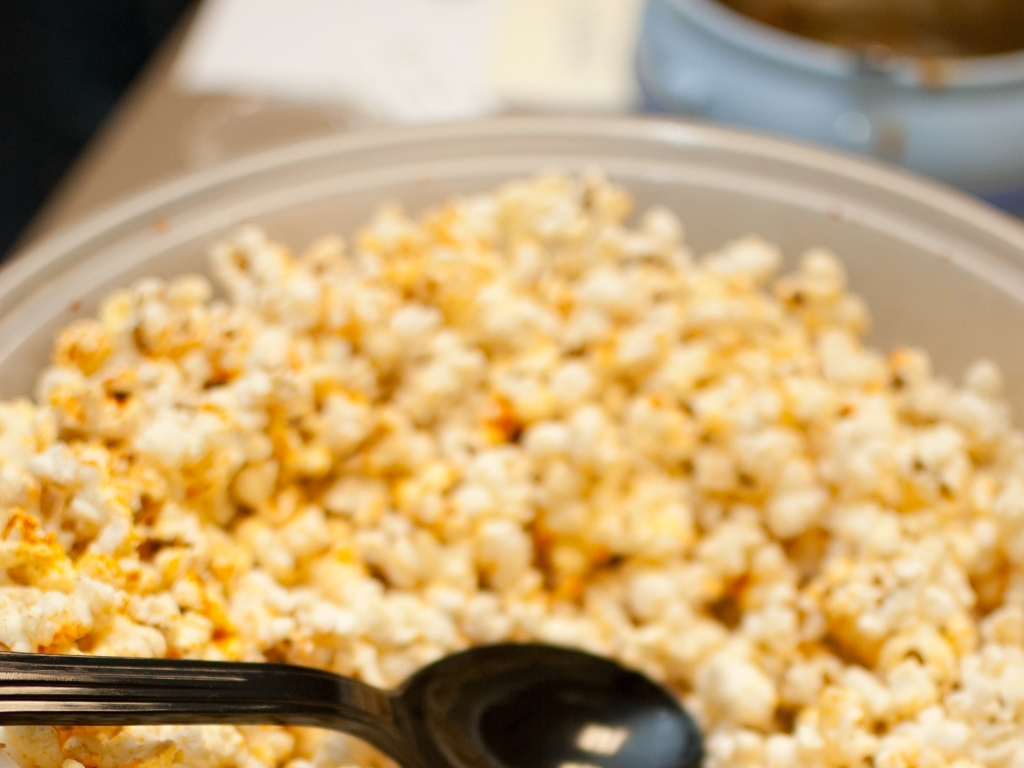Could you suggest a suitable beverage to accompany this snack? A refreshing complement to this savory seasoned popcorn could be a cold glass of sparkling water with a squeeze of fresh lime or lemon to cleanse the palate. If preferred, a light, chilled beer could also pair nicely, enhancing the relaxing snacking experience. 